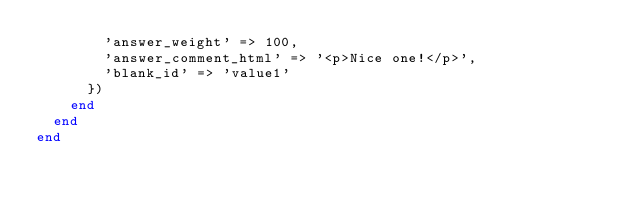Convert code to text. <code><loc_0><loc_0><loc_500><loc_500><_Ruby_>        'answer_weight' => 100,
        'answer_comment_html' => '<p>Nice one!</p>',
        'blank_id' => 'value1'
      })
    end
  end
end
</code> 